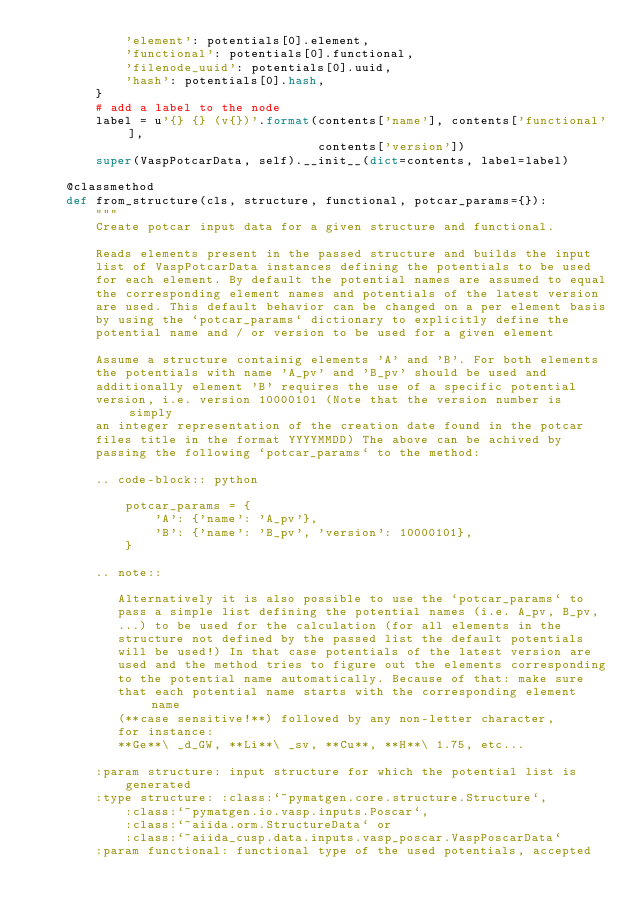<code> <loc_0><loc_0><loc_500><loc_500><_Python_>            'element': potentials[0].element,
            'functional': potentials[0].functional,
            'filenode_uuid': potentials[0].uuid,
            'hash': potentials[0].hash,
        }
        # add a label to the node
        label = u'{} {} (v{})'.format(contents['name'], contents['functional'],
                                      contents['version'])
        super(VaspPotcarData, self).__init__(dict=contents, label=label)

    @classmethod
    def from_structure(cls, structure, functional, potcar_params={}):
        """
        Create potcar input data for a given structure and functional.

        Reads elements present in the passed structure and builds the input
        list of VaspPotcarData instances defining the potentials to be used
        for each element. By default the potential names are assumed to equal
        the corresponding element names and potentials of the latest version
        are used. This default behavior can be changed on a per element basis
        by using the `potcar_params` dictionary to explicitly define the
        potential name and / or version to be used for a given element

        Assume a structure containig elements 'A' and 'B'. For both elements
        the potentials with name 'A_pv' and 'B_pv' should be used and
        additionally element 'B' requires the use of a specific potential
        version, i.e. version 10000101 (Note that the version number is simply
        an integer representation of the creation date found in the potcar
        files title in the format YYYYMMDD) The above can be achived by
        passing the following `potcar_params` to the method:

        .. code-block:: python

            potcar_params = {
                'A': {'name': 'A_pv'},
                'B': {'name': 'B_pv', 'version': 10000101},
            }

        .. note::

           Alternatively it is also possible to use the `potcar_params` to
           pass a simple list defining the potential names (i.e. A_pv, B_pv,
           ...) to be used for the calculation (for all elements in the
           structure not defined by the passed list the default potentials
           will be used!) In that case potentials of the latest version are
           used and the method tries to figure out the elements corresponding
           to the potential name automatically. Because of that: make sure
           that each potential name starts with the corresponding element name
           (**case sensitive!**) followed by any non-letter character,
           for instance:
           **Ge**\ _d_GW, **Li**\ _sv, **Cu**, **H**\ 1.75, etc...

        :param structure: input structure for which the potential list is
            generated
        :type structure: :class:`~pymatgen.core.structure.Structure`,
            :class:`~pymatgen.io.vasp.inputs.Poscar`,
            :class:`~aiida.orm.StructureData` or
            :class:`~aiida_cusp.data.inputs.vasp_poscar.VaspPoscarData`
        :param functional: functional type of the used potentials, accepted</code> 